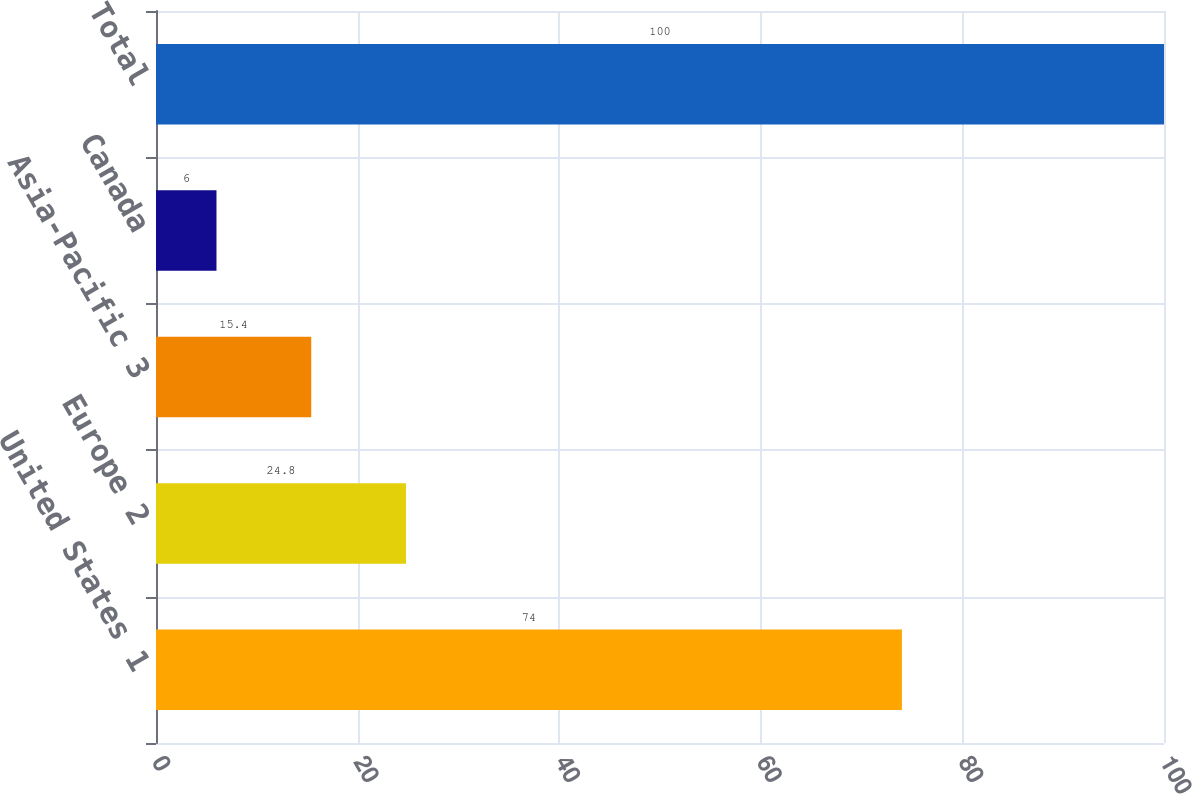<chart> <loc_0><loc_0><loc_500><loc_500><bar_chart><fcel>United States 1<fcel>Europe 2<fcel>Asia-Pacific 3<fcel>Canada<fcel>Total<nl><fcel>74<fcel>24.8<fcel>15.4<fcel>6<fcel>100<nl></chart> 